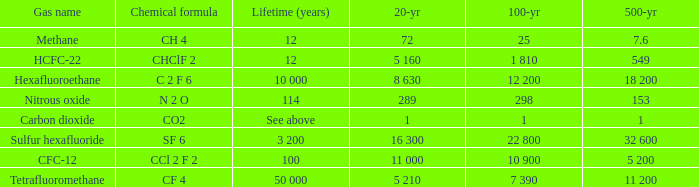What is the 100 year when 500 year is 153? 298.0. 